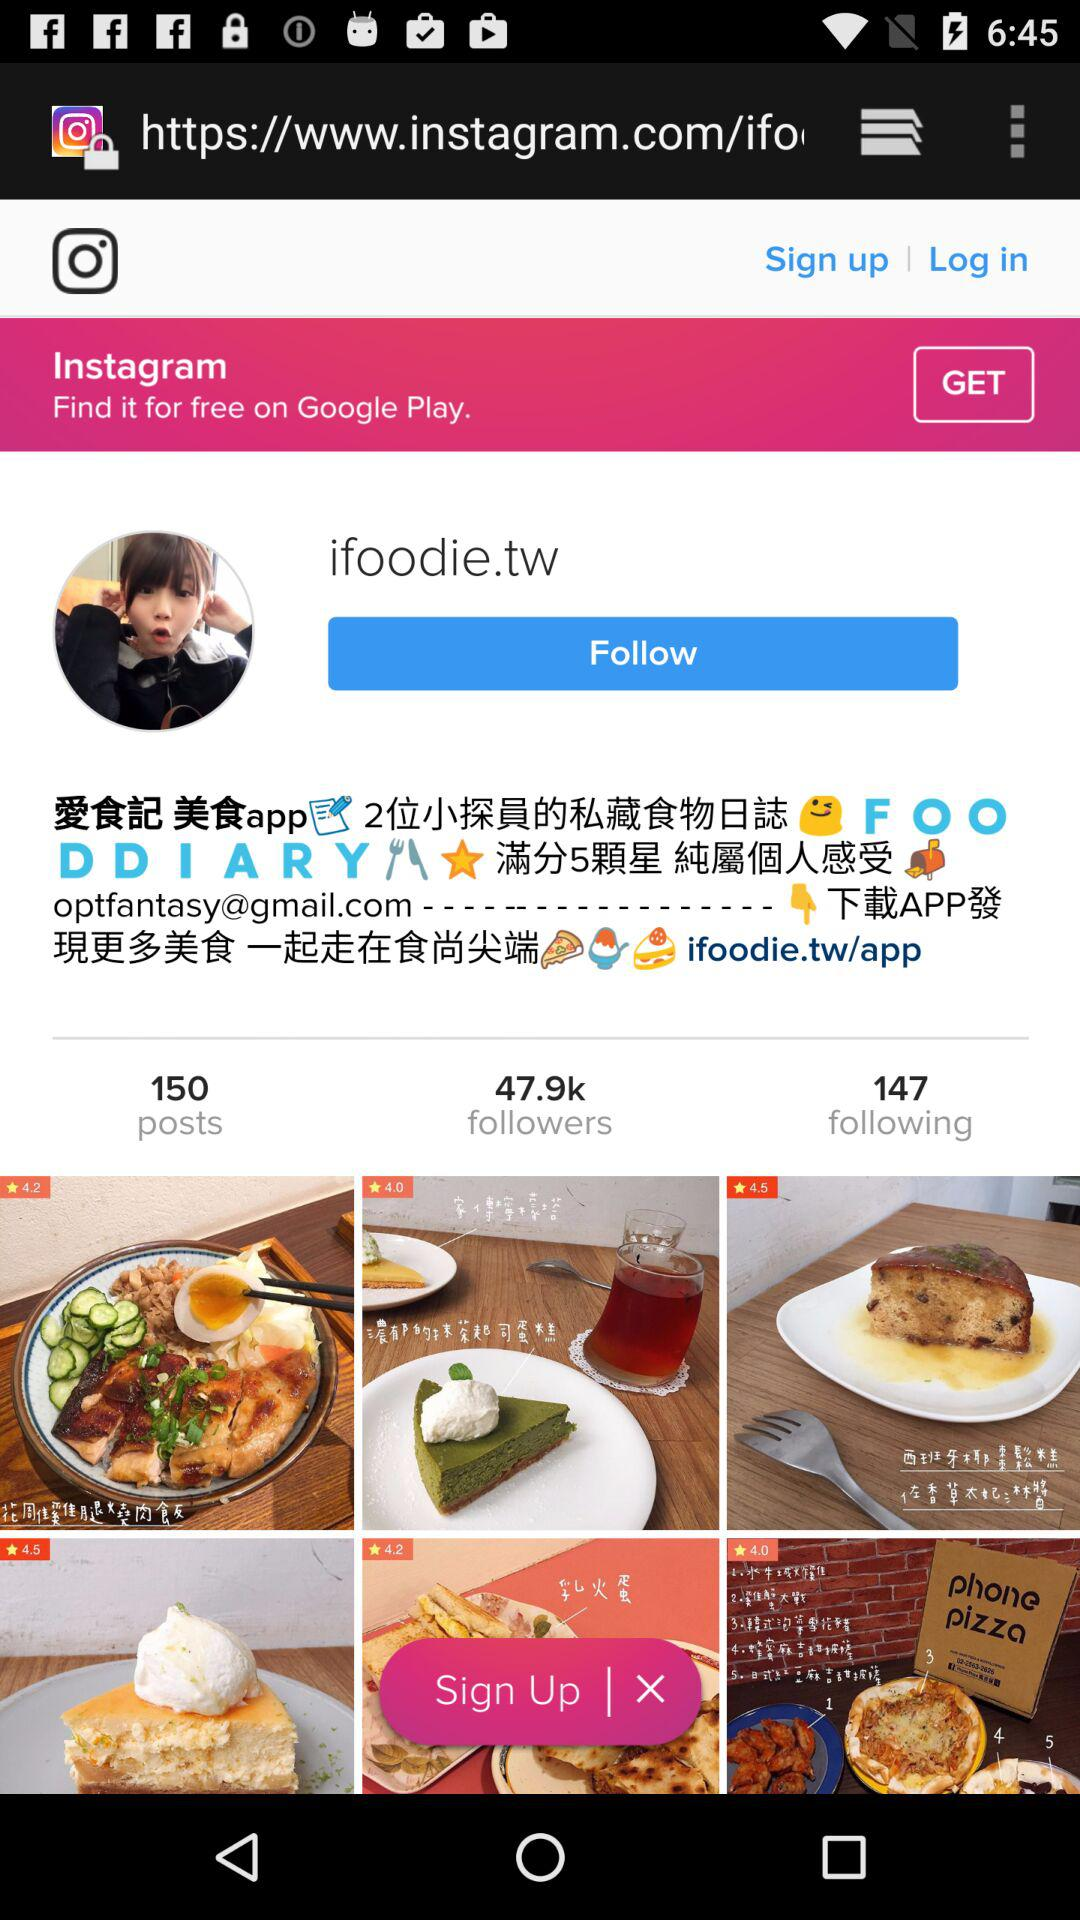How many following are there for "ifoodie.tw" There are 147 following. 